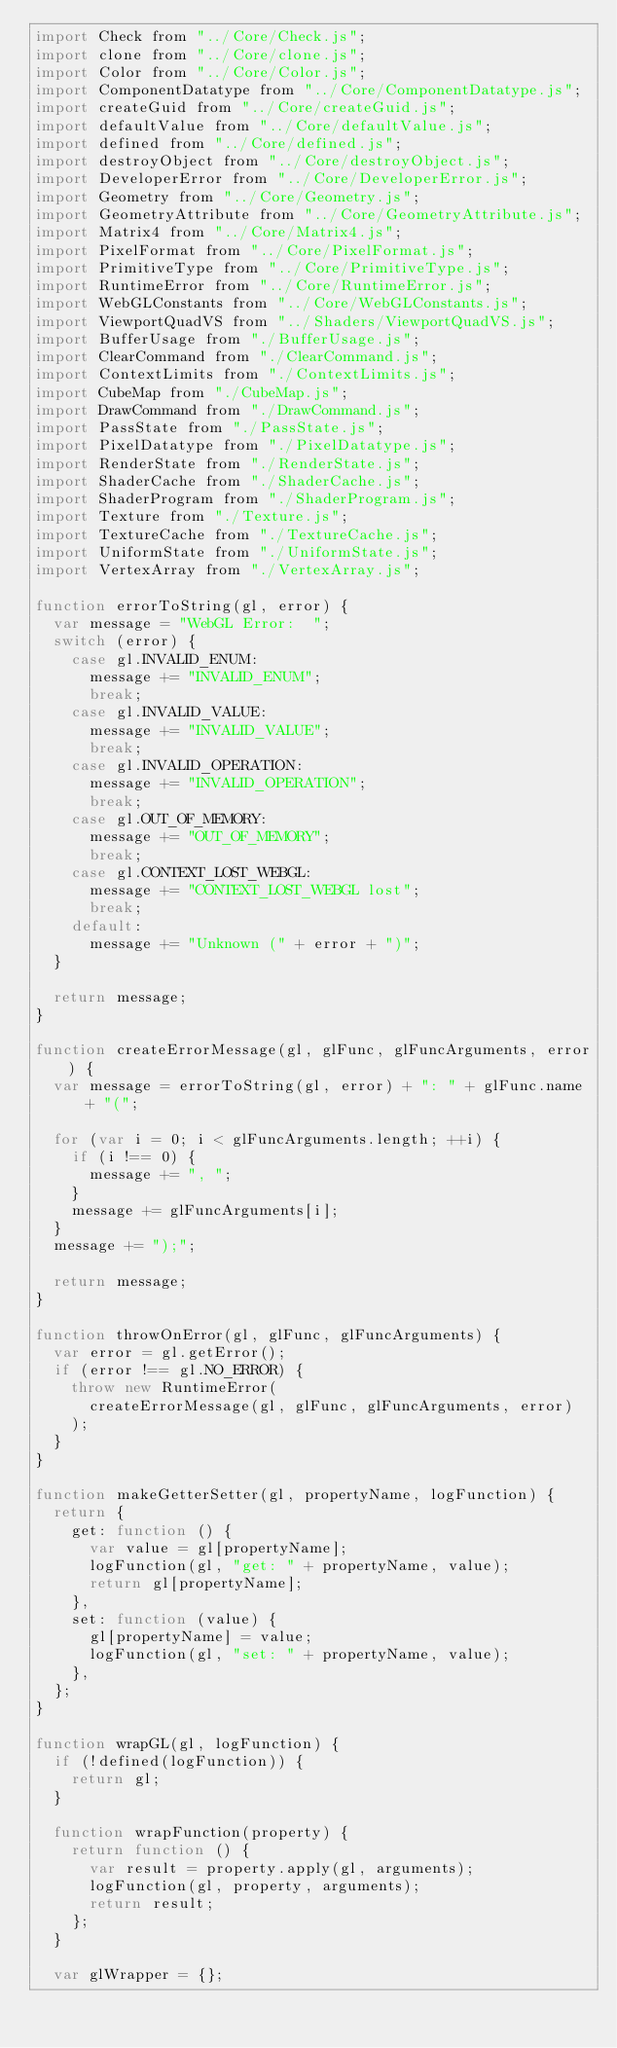Convert code to text. <code><loc_0><loc_0><loc_500><loc_500><_JavaScript_>import Check from "../Core/Check.js";
import clone from "../Core/clone.js";
import Color from "../Core/Color.js";
import ComponentDatatype from "../Core/ComponentDatatype.js";
import createGuid from "../Core/createGuid.js";
import defaultValue from "../Core/defaultValue.js";
import defined from "../Core/defined.js";
import destroyObject from "../Core/destroyObject.js";
import DeveloperError from "../Core/DeveloperError.js";
import Geometry from "../Core/Geometry.js";
import GeometryAttribute from "../Core/GeometryAttribute.js";
import Matrix4 from "../Core/Matrix4.js";
import PixelFormat from "../Core/PixelFormat.js";
import PrimitiveType from "../Core/PrimitiveType.js";
import RuntimeError from "../Core/RuntimeError.js";
import WebGLConstants from "../Core/WebGLConstants.js";
import ViewportQuadVS from "../Shaders/ViewportQuadVS.js";
import BufferUsage from "./BufferUsage.js";
import ClearCommand from "./ClearCommand.js";
import ContextLimits from "./ContextLimits.js";
import CubeMap from "./CubeMap.js";
import DrawCommand from "./DrawCommand.js";
import PassState from "./PassState.js";
import PixelDatatype from "./PixelDatatype.js";
import RenderState from "./RenderState.js";
import ShaderCache from "./ShaderCache.js";
import ShaderProgram from "./ShaderProgram.js";
import Texture from "./Texture.js";
import TextureCache from "./TextureCache.js";
import UniformState from "./UniformState.js";
import VertexArray from "./VertexArray.js";

function errorToString(gl, error) {
  var message = "WebGL Error:  ";
  switch (error) {
    case gl.INVALID_ENUM:
      message += "INVALID_ENUM";
      break;
    case gl.INVALID_VALUE:
      message += "INVALID_VALUE";
      break;
    case gl.INVALID_OPERATION:
      message += "INVALID_OPERATION";
      break;
    case gl.OUT_OF_MEMORY:
      message += "OUT_OF_MEMORY";
      break;
    case gl.CONTEXT_LOST_WEBGL:
      message += "CONTEXT_LOST_WEBGL lost";
      break;
    default:
      message += "Unknown (" + error + ")";
  }

  return message;
}

function createErrorMessage(gl, glFunc, glFuncArguments, error) {
  var message = errorToString(gl, error) + ": " + glFunc.name + "(";

  for (var i = 0; i < glFuncArguments.length; ++i) {
    if (i !== 0) {
      message += ", ";
    }
    message += glFuncArguments[i];
  }
  message += ");";

  return message;
}

function throwOnError(gl, glFunc, glFuncArguments) {
  var error = gl.getError();
  if (error !== gl.NO_ERROR) {
    throw new RuntimeError(
      createErrorMessage(gl, glFunc, glFuncArguments, error)
    );
  }
}

function makeGetterSetter(gl, propertyName, logFunction) {
  return {
    get: function () {
      var value = gl[propertyName];
      logFunction(gl, "get: " + propertyName, value);
      return gl[propertyName];
    },
    set: function (value) {
      gl[propertyName] = value;
      logFunction(gl, "set: " + propertyName, value);
    },
  };
}

function wrapGL(gl, logFunction) {
  if (!defined(logFunction)) {
    return gl;
  }

  function wrapFunction(property) {
    return function () {
      var result = property.apply(gl, arguments);
      logFunction(gl, property, arguments);
      return result;
    };
  }

  var glWrapper = {};
</code> 